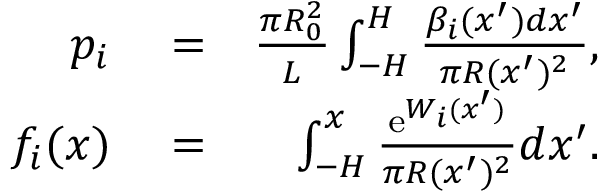<formula> <loc_0><loc_0><loc_500><loc_500>\begin{array} { r l r } { p _ { i } } & = } & { \frac { \pi R _ { 0 } ^ { 2 } } { L } \int _ { - H } ^ { H } \frac { \beta _ { i } ( x ^ { \prime } ) d x ^ { \prime } } { \pi R ( x ^ { \prime } ) ^ { 2 } } , } \\ { f _ { i } ( x ) } & = } & { \int _ { - H } ^ { x } \frac { e ^ { W _ { i } ( x ^ { \prime } ) } } { \pi R ( x ^ { \prime } ) ^ { 2 } } d x ^ { \prime } . } \end{array}</formula> 